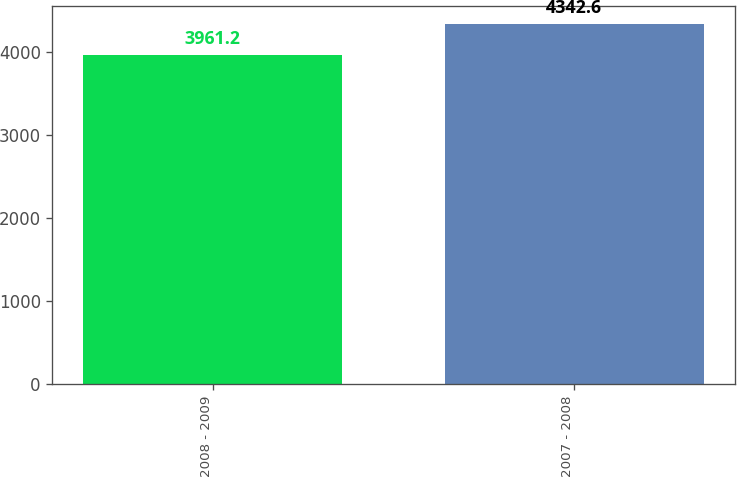Convert chart to OTSL. <chart><loc_0><loc_0><loc_500><loc_500><bar_chart><fcel>2008 - 2009<fcel>2007 - 2008<nl><fcel>3961.2<fcel>4342.6<nl></chart> 